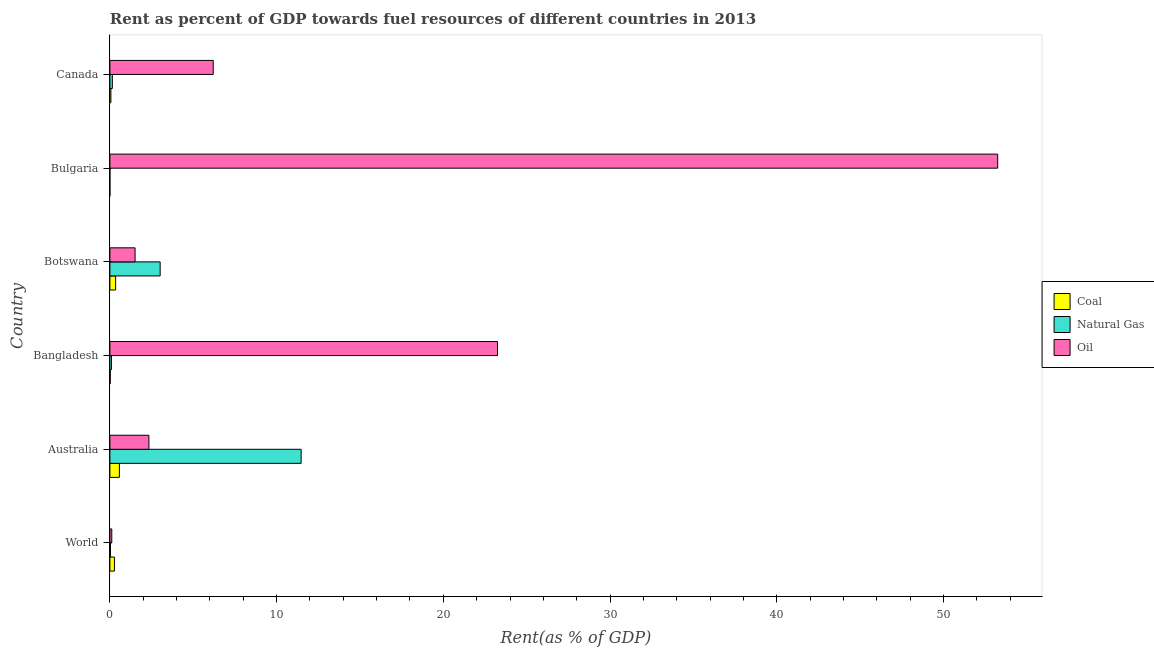Are the number of bars per tick equal to the number of legend labels?
Provide a short and direct response. Yes. How many bars are there on the 3rd tick from the top?
Make the answer very short. 3. In how many cases, is the number of bars for a given country not equal to the number of legend labels?
Your response must be concise. 0. What is the rent towards oil in Australia?
Offer a very short reply. 2.34. Across all countries, what is the maximum rent towards natural gas?
Offer a terse response. 11.47. Across all countries, what is the minimum rent towards oil?
Make the answer very short. 0.11. What is the total rent towards natural gas in the graph?
Make the answer very short. 14.76. What is the difference between the rent towards oil in Australia and that in Canada?
Your answer should be compact. -3.86. What is the difference between the rent towards coal in Bangladesh and the rent towards oil in Bulgaria?
Provide a succinct answer. -53.23. What is the average rent towards oil per country?
Your answer should be compact. 14.44. What is the difference between the rent towards oil and rent towards coal in Botswana?
Your answer should be very brief. 1.17. In how many countries, is the rent towards oil greater than 4 %?
Keep it short and to the point. 3. What is the ratio of the rent towards natural gas in Bangladesh to that in World?
Provide a short and direct response. 2.74. Is the rent towards oil in Bangladesh less than that in Canada?
Offer a terse response. No. Is the difference between the rent towards natural gas in Bangladesh and Bulgaria greater than the difference between the rent towards coal in Bangladesh and Bulgaria?
Keep it short and to the point. Yes. What is the difference between the highest and the second highest rent towards natural gas?
Offer a terse response. 8.46. What is the difference between the highest and the lowest rent towards oil?
Offer a very short reply. 53.14. In how many countries, is the rent towards natural gas greater than the average rent towards natural gas taken over all countries?
Offer a terse response. 2. What does the 2nd bar from the top in Canada represents?
Keep it short and to the point. Natural Gas. What does the 2nd bar from the bottom in Botswana represents?
Keep it short and to the point. Natural Gas. How many bars are there?
Keep it short and to the point. 18. How many countries are there in the graph?
Your answer should be very brief. 6. Are the values on the major ticks of X-axis written in scientific E-notation?
Ensure brevity in your answer.  No. Does the graph contain any zero values?
Ensure brevity in your answer.  No. Where does the legend appear in the graph?
Offer a very short reply. Center right. How many legend labels are there?
Give a very brief answer. 3. What is the title of the graph?
Your answer should be very brief. Rent as percent of GDP towards fuel resources of different countries in 2013. What is the label or title of the X-axis?
Ensure brevity in your answer.  Rent(as % of GDP). What is the label or title of the Y-axis?
Offer a terse response. Country. What is the Rent(as % of GDP) of Coal in World?
Your answer should be compact. 0.27. What is the Rent(as % of GDP) in Natural Gas in World?
Offer a terse response. 0.03. What is the Rent(as % of GDP) of Oil in World?
Provide a succinct answer. 0.11. What is the Rent(as % of GDP) of Coal in Australia?
Keep it short and to the point. 0.57. What is the Rent(as % of GDP) of Natural Gas in Australia?
Offer a very short reply. 11.47. What is the Rent(as % of GDP) in Oil in Australia?
Your answer should be compact. 2.34. What is the Rent(as % of GDP) of Coal in Bangladesh?
Make the answer very short. 0.02. What is the Rent(as % of GDP) in Natural Gas in Bangladesh?
Provide a succinct answer. 0.09. What is the Rent(as % of GDP) in Oil in Bangladesh?
Offer a very short reply. 23.25. What is the Rent(as % of GDP) in Coal in Botswana?
Offer a terse response. 0.34. What is the Rent(as % of GDP) in Natural Gas in Botswana?
Offer a very short reply. 3.02. What is the Rent(as % of GDP) of Oil in Botswana?
Make the answer very short. 1.51. What is the Rent(as % of GDP) in Coal in Bulgaria?
Your answer should be very brief. 0. What is the Rent(as % of GDP) of Natural Gas in Bulgaria?
Your response must be concise. 0. What is the Rent(as % of GDP) in Oil in Bulgaria?
Provide a succinct answer. 53.25. What is the Rent(as % of GDP) in Coal in Canada?
Provide a short and direct response. 0.06. What is the Rent(as % of GDP) in Natural Gas in Canada?
Make the answer very short. 0.15. What is the Rent(as % of GDP) in Oil in Canada?
Ensure brevity in your answer.  6.2. Across all countries, what is the maximum Rent(as % of GDP) in Coal?
Ensure brevity in your answer.  0.57. Across all countries, what is the maximum Rent(as % of GDP) of Natural Gas?
Offer a terse response. 11.47. Across all countries, what is the maximum Rent(as % of GDP) in Oil?
Your answer should be very brief. 53.25. Across all countries, what is the minimum Rent(as % of GDP) of Coal?
Make the answer very short. 0. Across all countries, what is the minimum Rent(as % of GDP) in Natural Gas?
Keep it short and to the point. 0. Across all countries, what is the minimum Rent(as % of GDP) of Oil?
Ensure brevity in your answer.  0.11. What is the total Rent(as % of GDP) of Coal in the graph?
Provide a succinct answer. 1.27. What is the total Rent(as % of GDP) of Natural Gas in the graph?
Keep it short and to the point. 14.76. What is the total Rent(as % of GDP) of Oil in the graph?
Your response must be concise. 86.67. What is the difference between the Rent(as % of GDP) of Coal in World and that in Australia?
Your response must be concise. -0.3. What is the difference between the Rent(as % of GDP) in Natural Gas in World and that in Australia?
Keep it short and to the point. -11.44. What is the difference between the Rent(as % of GDP) in Oil in World and that in Australia?
Ensure brevity in your answer.  -2.23. What is the difference between the Rent(as % of GDP) of Coal in World and that in Bangladesh?
Keep it short and to the point. 0.25. What is the difference between the Rent(as % of GDP) of Natural Gas in World and that in Bangladesh?
Your answer should be compact. -0.06. What is the difference between the Rent(as % of GDP) of Oil in World and that in Bangladesh?
Your answer should be very brief. -23.14. What is the difference between the Rent(as % of GDP) of Coal in World and that in Botswana?
Offer a terse response. -0.07. What is the difference between the Rent(as % of GDP) in Natural Gas in World and that in Botswana?
Keep it short and to the point. -2.98. What is the difference between the Rent(as % of GDP) of Oil in World and that in Botswana?
Provide a succinct answer. -1.4. What is the difference between the Rent(as % of GDP) of Coal in World and that in Bulgaria?
Provide a succinct answer. 0.27. What is the difference between the Rent(as % of GDP) of Natural Gas in World and that in Bulgaria?
Your answer should be compact. 0.03. What is the difference between the Rent(as % of GDP) in Oil in World and that in Bulgaria?
Ensure brevity in your answer.  -53.14. What is the difference between the Rent(as % of GDP) of Coal in World and that in Canada?
Provide a succinct answer. 0.21. What is the difference between the Rent(as % of GDP) in Natural Gas in World and that in Canada?
Make the answer very short. -0.11. What is the difference between the Rent(as % of GDP) in Oil in World and that in Canada?
Ensure brevity in your answer.  -6.08. What is the difference between the Rent(as % of GDP) in Coal in Australia and that in Bangladesh?
Provide a short and direct response. 0.55. What is the difference between the Rent(as % of GDP) of Natural Gas in Australia and that in Bangladesh?
Keep it short and to the point. 11.38. What is the difference between the Rent(as % of GDP) of Oil in Australia and that in Bangladesh?
Make the answer very short. -20.91. What is the difference between the Rent(as % of GDP) of Coal in Australia and that in Botswana?
Make the answer very short. 0.22. What is the difference between the Rent(as % of GDP) in Natural Gas in Australia and that in Botswana?
Keep it short and to the point. 8.46. What is the difference between the Rent(as % of GDP) of Oil in Australia and that in Botswana?
Your response must be concise. 0.83. What is the difference between the Rent(as % of GDP) in Coal in Australia and that in Bulgaria?
Your answer should be compact. 0.57. What is the difference between the Rent(as % of GDP) of Natural Gas in Australia and that in Bulgaria?
Offer a terse response. 11.47. What is the difference between the Rent(as % of GDP) of Oil in Australia and that in Bulgaria?
Provide a short and direct response. -50.91. What is the difference between the Rent(as % of GDP) of Coal in Australia and that in Canada?
Your answer should be very brief. 0.51. What is the difference between the Rent(as % of GDP) of Natural Gas in Australia and that in Canada?
Offer a very short reply. 11.32. What is the difference between the Rent(as % of GDP) in Oil in Australia and that in Canada?
Provide a succinct answer. -3.86. What is the difference between the Rent(as % of GDP) in Coal in Bangladesh and that in Botswana?
Your answer should be compact. -0.32. What is the difference between the Rent(as % of GDP) in Natural Gas in Bangladesh and that in Botswana?
Give a very brief answer. -2.92. What is the difference between the Rent(as % of GDP) of Oil in Bangladesh and that in Botswana?
Provide a short and direct response. 21.74. What is the difference between the Rent(as % of GDP) in Coal in Bangladesh and that in Bulgaria?
Make the answer very short. 0.02. What is the difference between the Rent(as % of GDP) of Natural Gas in Bangladesh and that in Bulgaria?
Provide a succinct answer. 0.09. What is the difference between the Rent(as % of GDP) of Oil in Bangladesh and that in Bulgaria?
Make the answer very short. -30. What is the difference between the Rent(as % of GDP) of Coal in Bangladesh and that in Canada?
Your response must be concise. -0.04. What is the difference between the Rent(as % of GDP) of Natural Gas in Bangladesh and that in Canada?
Provide a short and direct response. -0.05. What is the difference between the Rent(as % of GDP) in Oil in Bangladesh and that in Canada?
Offer a very short reply. 17.05. What is the difference between the Rent(as % of GDP) of Coal in Botswana and that in Bulgaria?
Make the answer very short. 0.34. What is the difference between the Rent(as % of GDP) of Natural Gas in Botswana and that in Bulgaria?
Provide a succinct answer. 3.02. What is the difference between the Rent(as % of GDP) in Oil in Botswana and that in Bulgaria?
Your answer should be very brief. -51.74. What is the difference between the Rent(as % of GDP) in Coal in Botswana and that in Canada?
Your response must be concise. 0.28. What is the difference between the Rent(as % of GDP) in Natural Gas in Botswana and that in Canada?
Your answer should be very brief. 2.87. What is the difference between the Rent(as % of GDP) of Oil in Botswana and that in Canada?
Your answer should be very brief. -4.69. What is the difference between the Rent(as % of GDP) in Coal in Bulgaria and that in Canada?
Offer a terse response. -0.06. What is the difference between the Rent(as % of GDP) in Natural Gas in Bulgaria and that in Canada?
Keep it short and to the point. -0.15. What is the difference between the Rent(as % of GDP) of Oil in Bulgaria and that in Canada?
Your response must be concise. 47.06. What is the difference between the Rent(as % of GDP) of Coal in World and the Rent(as % of GDP) of Natural Gas in Australia?
Offer a very short reply. -11.2. What is the difference between the Rent(as % of GDP) of Coal in World and the Rent(as % of GDP) of Oil in Australia?
Provide a short and direct response. -2.07. What is the difference between the Rent(as % of GDP) of Natural Gas in World and the Rent(as % of GDP) of Oil in Australia?
Offer a very short reply. -2.31. What is the difference between the Rent(as % of GDP) in Coal in World and the Rent(as % of GDP) in Natural Gas in Bangladesh?
Keep it short and to the point. 0.18. What is the difference between the Rent(as % of GDP) in Coal in World and the Rent(as % of GDP) in Oil in Bangladesh?
Offer a terse response. -22.98. What is the difference between the Rent(as % of GDP) of Natural Gas in World and the Rent(as % of GDP) of Oil in Bangladesh?
Offer a very short reply. -23.22. What is the difference between the Rent(as % of GDP) of Coal in World and the Rent(as % of GDP) of Natural Gas in Botswana?
Your answer should be very brief. -2.74. What is the difference between the Rent(as % of GDP) in Coal in World and the Rent(as % of GDP) in Oil in Botswana?
Keep it short and to the point. -1.24. What is the difference between the Rent(as % of GDP) in Natural Gas in World and the Rent(as % of GDP) in Oil in Botswana?
Provide a short and direct response. -1.48. What is the difference between the Rent(as % of GDP) in Coal in World and the Rent(as % of GDP) in Natural Gas in Bulgaria?
Your response must be concise. 0.27. What is the difference between the Rent(as % of GDP) of Coal in World and the Rent(as % of GDP) of Oil in Bulgaria?
Provide a short and direct response. -52.98. What is the difference between the Rent(as % of GDP) of Natural Gas in World and the Rent(as % of GDP) of Oil in Bulgaria?
Keep it short and to the point. -53.22. What is the difference between the Rent(as % of GDP) of Coal in World and the Rent(as % of GDP) of Natural Gas in Canada?
Provide a short and direct response. 0.13. What is the difference between the Rent(as % of GDP) of Coal in World and the Rent(as % of GDP) of Oil in Canada?
Your answer should be very brief. -5.92. What is the difference between the Rent(as % of GDP) of Natural Gas in World and the Rent(as % of GDP) of Oil in Canada?
Make the answer very short. -6.16. What is the difference between the Rent(as % of GDP) in Coal in Australia and the Rent(as % of GDP) in Natural Gas in Bangladesh?
Give a very brief answer. 0.48. What is the difference between the Rent(as % of GDP) in Coal in Australia and the Rent(as % of GDP) in Oil in Bangladesh?
Ensure brevity in your answer.  -22.68. What is the difference between the Rent(as % of GDP) of Natural Gas in Australia and the Rent(as % of GDP) of Oil in Bangladesh?
Provide a succinct answer. -11.78. What is the difference between the Rent(as % of GDP) of Coal in Australia and the Rent(as % of GDP) of Natural Gas in Botswana?
Ensure brevity in your answer.  -2.45. What is the difference between the Rent(as % of GDP) of Coal in Australia and the Rent(as % of GDP) of Oil in Botswana?
Your response must be concise. -0.94. What is the difference between the Rent(as % of GDP) in Natural Gas in Australia and the Rent(as % of GDP) in Oil in Botswana?
Provide a succinct answer. 9.96. What is the difference between the Rent(as % of GDP) of Coal in Australia and the Rent(as % of GDP) of Natural Gas in Bulgaria?
Give a very brief answer. 0.57. What is the difference between the Rent(as % of GDP) in Coal in Australia and the Rent(as % of GDP) in Oil in Bulgaria?
Offer a terse response. -52.68. What is the difference between the Rent(as % of GDP) in Natural Gas in Australia and the Rent(as % of GDP) in Oil in Bulgaria?
Give a very brief answer. -41.78. What is the difference between the Rent(as % of GDP) in Coal in Australia and the Rent(as % of GDP) in Natural Gas in Canada?
Provide a succinct answer. 0.42. What is the difference between the Rent(as % of GDP) of Coal in Australia and the Rent(as % of GDP) of Oil in Canada?
Your answer should be very brief. -5.63. What is the difference between the Rent(as % of GDP) of Natural Gas in Australia and the Rent(as % of GDP) of Oil in Canada?
Ensure brevity in your answer.  5.27. What is the difference between the Rent(as % of GDP) of Coal in Bangladesh and the Rent(as % of GDP) of Natural Gas in Botswana?
Offer a very short reply. -2.99. What is the difference between the Rent(as % of GDP) in Coal in Bangladesh and the Rent(as % of GDP) in Oil in Botswana?
Ensure brevity in your answer.  -1.49. What is the difference between the Rent(as % of GDP) of Natural Gas in Bangladesh and the Rent(as % of GDP) of Oil in Botswana?
Give a very brief answer. -1.42. What is the difference between the Rent(as % of GDP) in Coal in Bangladesh and the Rent(as % of GDP) in Natural Gas in Bulgaria?
Your response must be concise. 0.02. What is the difference between the Rent(as % of GDP) in Coal in Bangladesh and the Rent(as % of GDP) in Oil in Bulgaria?
Make the answer very short. -53.23. What is the difference between the Rent(as % of GDP) in Natural Gas in Bangladesh and the Rent(as % of GDP) in Oil in Bulgaria?
Your response must be concise. -53.16. What is the difference between the Rent(as % of GDP) of Coal in Bangladesh and the Rent(as % of GDP) of Natural Gas in Canada?
Your answer should be compact. -0.12. What is the difference between the Rent(as % of GDP) in Coal in Bangladesh and the Rent(as % of GDP) in Oil in Canada?
Keep it short and to the point. -6.18. What is the difference between the Rent(as % of GDP) in Natural Gas in Bangladesh and the Rent(as % of GDP) in Oil in Canada?
Offer a terse response. -6.1. What is the difference between the Rent(as % of GDP) of Coal in Botswana and the Rent(as % of GDP) of Natural Gas in Bulgaria?
Offer a terse response. 0.34. What is the difference between the Rent(as % of GDP) of Coal in Botswana and the Rent(as % of GDP) of Oil in Bulgaria?
Provide a short and direct response. -52.91. What is the difference between the Rent(as % of GDP) in Natural Gas in Botswana and the Rent(as % of GDP) in Oil in Bulgaria?
Provide a succinct answer. -50.24. What is the difference between the Rent(as % of GDP) in Coal in Botswana and the Rent(as % of GDP) in Natural Gas in Canada?
Your answer should be very brief. 0.2. What is the difference between the Rent(as % of GDP) of Coal in Botswana and the Rent(as % of GDP) of Oil in Canada?
Offer a very short reply. -5.85. What is the difference between the Rent(as % of GDP) in Natural Gas in Botswana and the Rent(as % of GDP) in Oil in Canada?
Provide a short and direct response. -3.18. What is the difference between the Rent(as % of GDP) in Coal in Bulgaria and the Rent(as % of GDP) in Natural Gas in Canada?
Provide a short and direct response. -0.15. What is the difference between the Rent(as % of GDP) of Coal in Bulgaria and the Rent(as % of GDP) of Oil in Canada?
Your response must be concise. -6.2. What is the difference between the Rent(as % of GDP) of Natural Gas in Bulgaria and the Rent(as % of GDP) of Oil in Canada?
Give a very brief answer. -6.2. What is the average Rent(as % of GDP) of Coal per country?
Offer a terse response. 0.21. What is the average Rent(as % of GDP) in Natural Gas per country?
Provide a short and direct response. 2.46. What is the average Rent(as % of GDP) of Oil per country?
Ensure brevity in your answer.  14.44. What is the difference between the Rent(as % of GDP) of Coal and Rent(as % of GDP) of Natural Gas in World?
Make the answer very short. 0.24. What is the difference between the Rent(as % of GDP) of Coal and Rent(as % of GDP) of Oil in World?
Provide a succinct answer. 0.16. What is the difference between the Rent(as % of GDP) of Natural Gas and Rent(as % of GDP) of Oil in World?
Offer a very short reply. -0.08. What is the difference between the Rent(as % of GDP) in Coal and Rent(as % of GDP) in Natural Gas in Australia?
Provide a short and direct response. -10.9. What is the difference between the Rent(as % of GDP) of Coal and Rent(as % of GDP) of Oil in Australia?
Your response must be concise. -1.77. What is the difference between the Rent(as % of GDP) in Natural Gas and Rent(as % of GDP) in Oil in Australia?
Keep it short and to the point. 9.13. What is the difference between the Rent(as % of GDP) in Coal and Rent(as % of GDP) in Natural Gas in Bangladesh?
Your response must be concise. -0.07. What is the difference between the Rent(as % of GDP) of Coal and Rent(as % of GDP) of Oil in Bangladesh?
Offer a terse response. -23.23. What is the difference between the Rent(as % of GDP) of Natural Gas and Rent(as % of GDP) of Oil in Bangladesh?
Your answer should be compact. -23.16. What is the difference between the Rent(as % of GDP) in Coal and Rent(as % of GDP) in Natural Gas in Botswana?
Your answer should be compact. -2.67. What is the difference between the Rent(as % of GDP) of Coal and Rent(as % of GDP) of Oil in Botswana?
Offer a terse response. -1.17. What is the difference between the Rent(as % of GDP) in Natural Gas and Rent(as % of GDP) in Oil in Botswana?
Ensure brevity in your answer.  1.5. What is the difference between the Rent(as % of GDP) of Coal and Rent(as % of GDP) of Oil in Bulgaria?
Keep it short and to the point. -53.25. What is the difference between the Rent(as % of GDP) of Natural Gas and Rent(as % of GDP) of Oil in Bulgaria?
Provide a succinct answer. -53.25. What is the difference between the Rent(as % of GDP) in Coal and Rent(as % of GDP) in Natural Gas in Canada?
Your answer should be very brief. -0.09. What is the difference between the Rent(as % of GDP) in Coal and Rent(as % of GDP) in Oil in Canada?
Offer a terse response. -6.14. What is the difference between the Rent(as % of GDP) of Natural Gas and Rent(as % of GDP) of Oil in Canada?
Your answer should be very brief. -6.05. What is the ratio of the Rent(as % of GDP) in Coal in World to that in Australia?
Provide a short and direct response. 0.48. What is the ratio of the Rent(as % of GDP) of Natural Gas in World to that in Australia?
Ensure brevity in your answer.  0. What is the ratio of the Rent(as % of GDP) of Oil in World to that in Australia?
Your response must be concise. 0.05. What is the ratio of the Rent(as % of GDP) in Coal in World to that in Bangladesh?
Give a very brief answer. 12.61. What is the ratio of the Rent(as % of GDP) of Natural Gas in World to that in Bangladesh?
Offer a terse response. 0.37. What is the ratio of the Rent(as % of GDP) in Oil in World to that in Bangladesh?
Your answer should be very brief. 0. What is the ratio of the Rent(as % of GDP) in Coal in World to that in Botswana?
Your response must be concise. 0.79. What is the ratio of the Rent(as % of GDP) in Natural Gas in World to that in Botswana?
Make the answer very short. 0.01. What is the ratio of the Rent(as % of GDP) of Oil in World to that in Botswana?
Give a very brief answer. 0.07. What is the ratio of the Rent(as % of GDP) in Coal in World to that in Bulgaria?
Your answer should be very brief. 1515.67. What is the ratio of the Rent(as % of GDP) in Natural Gas in World to that in Bulgaria?
Offer a very short reply. 289.62. What is the ratio of the Rent(as % of GDP) in Oil in World to that in Bulgaria?
Offer a very short reply. 0. What is the ratio of the Rent(as % of GDP) in Coal in World to that in Canada?
Offer a very short reply. 4.58. What is the ratio of the Rent(as % of GDP) in Natural Gas in World to that in Canada?
Give a very brief answer. 0.23. What is the ratio of the Rent(as % of GDP) in Oil in World to that in Canada?
Offer a very short reply. 0.02. What is the ratio of the Rent(as % of GDP) of Coal in Australia to that in Bangladesh?
Provide a short and direct response. 26.29. What is the ratio of the Rent(as % of GDP) in Natural Gas in Australia to that in Bangladesh?
Your answer should be compact. 122.92. What is the ratio of the Rent(as % of GDP) of Oil in Australia to that in Bangladesh?
Give a very brief answer. 0.1. What is the ratio of the Rent(as % of GDP) in Coal in Australia to that in Botswana?
Ensure brevity in your answer.  1.65. What is the ratio of the Rent(as % of GDP) in Natural Gas in Australia to that in Botswana?
Provide a short and direct response. 3.8. What is the ratio of the Rent(as % of GDP) in Oil in Australia to that in Botswana?
Provide a succinct answer. 1.55. What is the ratio of the Rent(as % of GDP) in Coal in Australia to that in Bulgaria?
Provide a succinct answer. 3160.35. What is the ratio of the Rent(as % of GDP) in Natural Gas in Australia to that in Bulgaria?
Make the answer very short. 9.74e+04. What is the ratio of the Rent(as % of GDP) in Oil in Australia to that in Bulgaria?
Ensure brevity in your answer.  0.04. What is the ratio of the Rent(as % of GDP) of Coal in Australia to that in Canada?
Your answer should be compact. 9.55. What is the ratio of the Rent(as % of GDP) of Natural Gas in Australia to that in Canada?
Give a very brief answer. 78.21. What is the ratio of the Rent(as % of GDP) in Oil in Australia to that in Canada?
Your answer should be compact. 0.38. What is the ratio of the Rent(as % of GDP) of Coal in Bangladesh to that in Botswana?
Your response must be concise. 0.06. What is the ratio of the Rent(as % of GDP) in Natural Gas in Bangladesh to that in Botswana?
Provide a short and direct response. 0.03. What is the ratio of the Rent(as % of GDP) in Oil in Bangladesh to that in Botswana?
Offer a terse response. 15.39. What is the ratio of the Rent(as % of GDP) in Coal in Bangladesh to that in Bulgaria?
Ensure brevity in your answer.  120.21. What is the ratio of the Rent(as % of GDP) in Natural Gas in Bangladesh to that in Bulgaria?
Provide a short and direct response. 792.64. What is the ratio of the Rent(as % of GDP) of Oil in Bangladesh to that in Bulgaria?
Keep it short and to the point. 0.44. What is the ratio of the Rent(as % of GDP) of Coal in Bangladesh to that in Canada?
Your response must be concise. 0.36. What is the ratio of the Rent(as % of GDP) in Natural Gas in Bangladesh to that in Canada?
Your answer should be compact. 0.64. What is the ratio of the Rent(as % of GDP) of Oil in Bangladesh to that in Canada?
Your answer should be very brief. 3.75. What is the ratio of the Rent(as % of GDP) of Coal in Botswana to that in Bulgaria?
Your answer should be compact. 1912.52. What is the ratio of the Rent(as % of GDP) of Natural Gas in Botswana to that in Bulgaria?
Your response must be concise. 2.56e+04. What is the ratio of the Rent(as % of GDP) of Oil in Botswana to that in Bulgaria?
Make the answer very short. 0.03. What is the ratio of the Rent(as % of GDP) in Coal in Botswana to that in Canada?
Make the answer very short. 5.78. What is the ratio of the Rent(as % of GDP) of Natural Gas in Botswana to that in Canada?
Provide a succinct answer. 20.56. What is the ratio of the Rent(as % of GDP) in Oil in Botswana to that in Canada?
Your answer should be compact. 0.24. What is the ratio of the Rent(as % of GDP) in Coal in Bulgaria to that in Canada?
Make the answer very short. 0. What is the ratio of the Rent(as % of GDP) in Natural Gas in Bulgaria to that in Canada?
Ensure brevity in your answer.  0. What is the ratio of the Rent(as % of GDP) in Oil in Bulgaria to that in Canada?
Give a very brief answer. 8.59. What is the difference between the highest and the second highest Rent(as % of GDP) in Coal?
Keep it short and to the point. 0.22. What is the difference between the highest and the second highest Rent(as % of GDP) in Natural Gas?
Provide a short and direct response. 8.46. What is the difference between the highest and the second highest Rent(as % of GDP) of Oil?
Keep it short and to the point. 30. What is the difference between the highest and the lowest Rent(as % of GDP) of Coal?
Make the answer very short. 0.57. What is the difference between the highest and the lowest Rent(as % of GDP) in Natural Gas?
Your answer should be very brief. 11.47. What is the difference between the highest and the lowest Rent(as % of GDP) of Oil?
Make the answer very short. 53.14. 